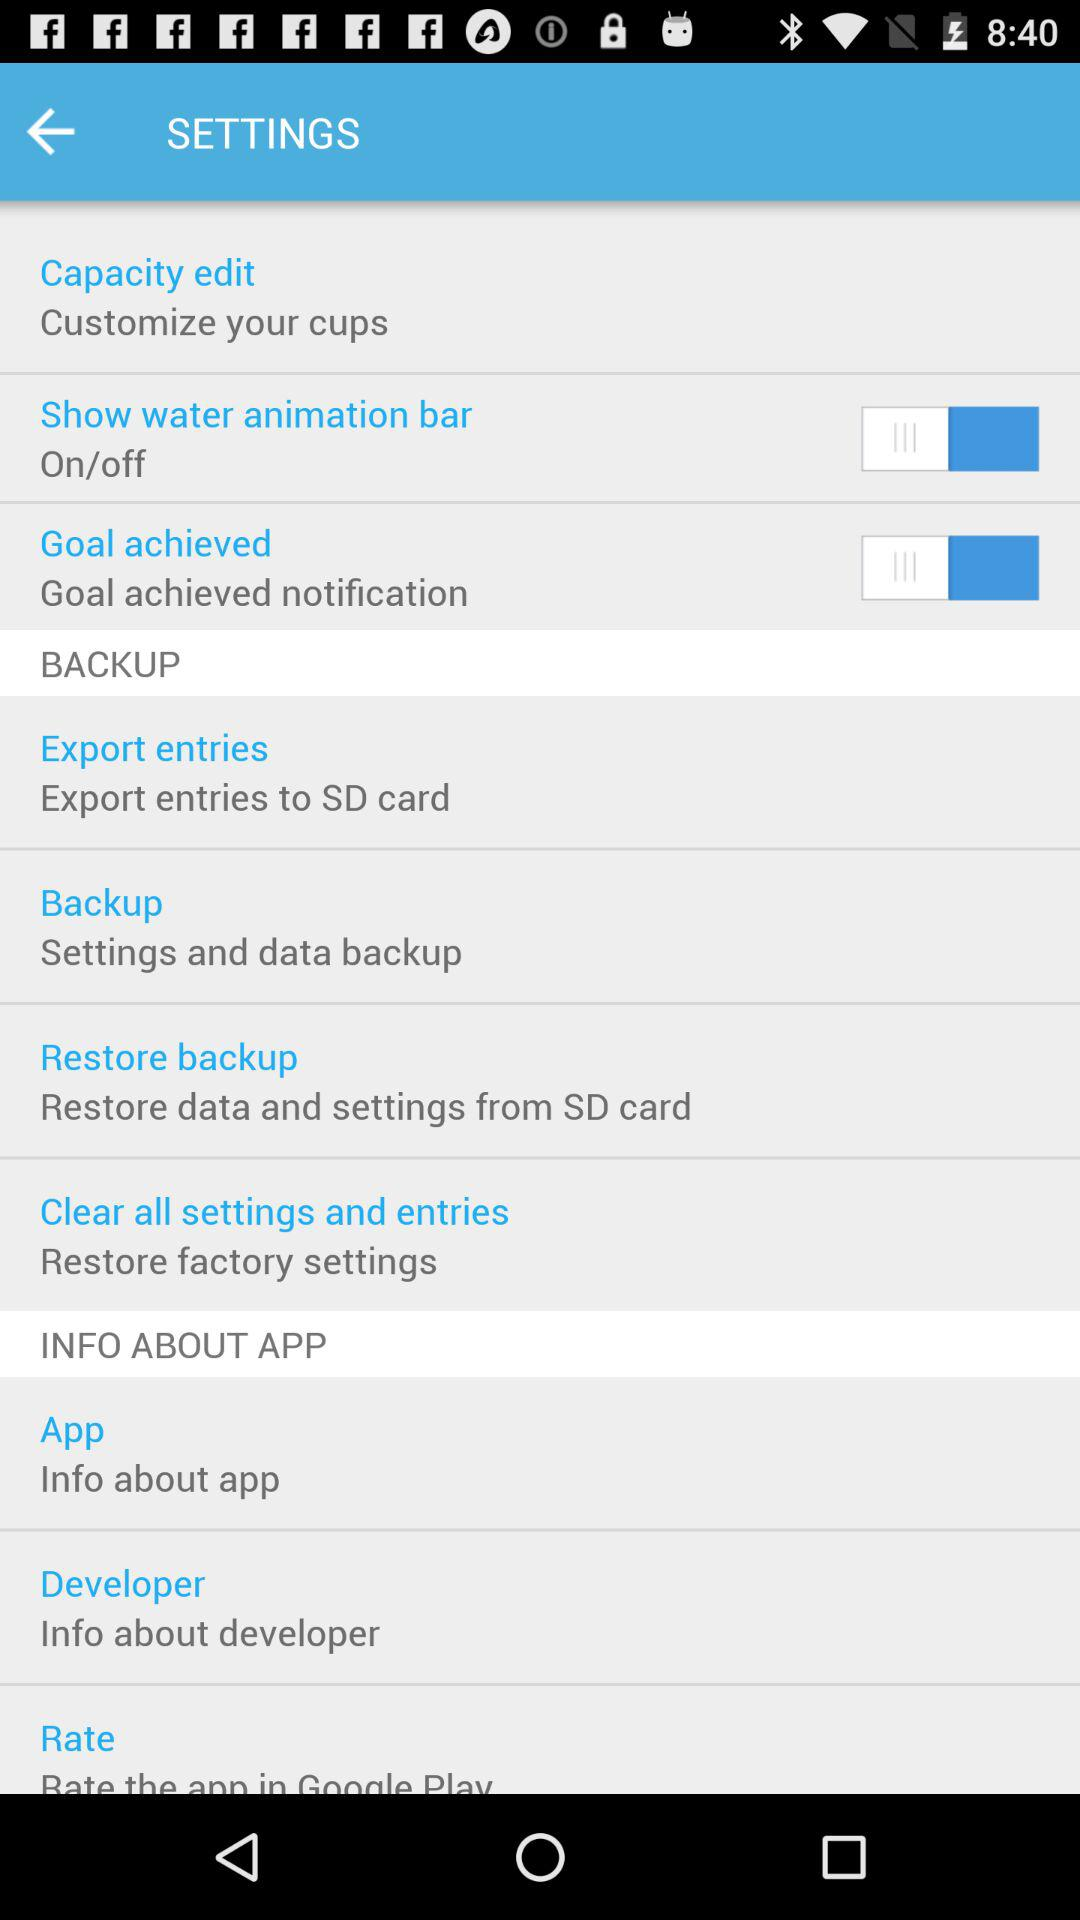How many items are in the Backup section that have a switch?
Answer the question using a single word or phrase. 2 